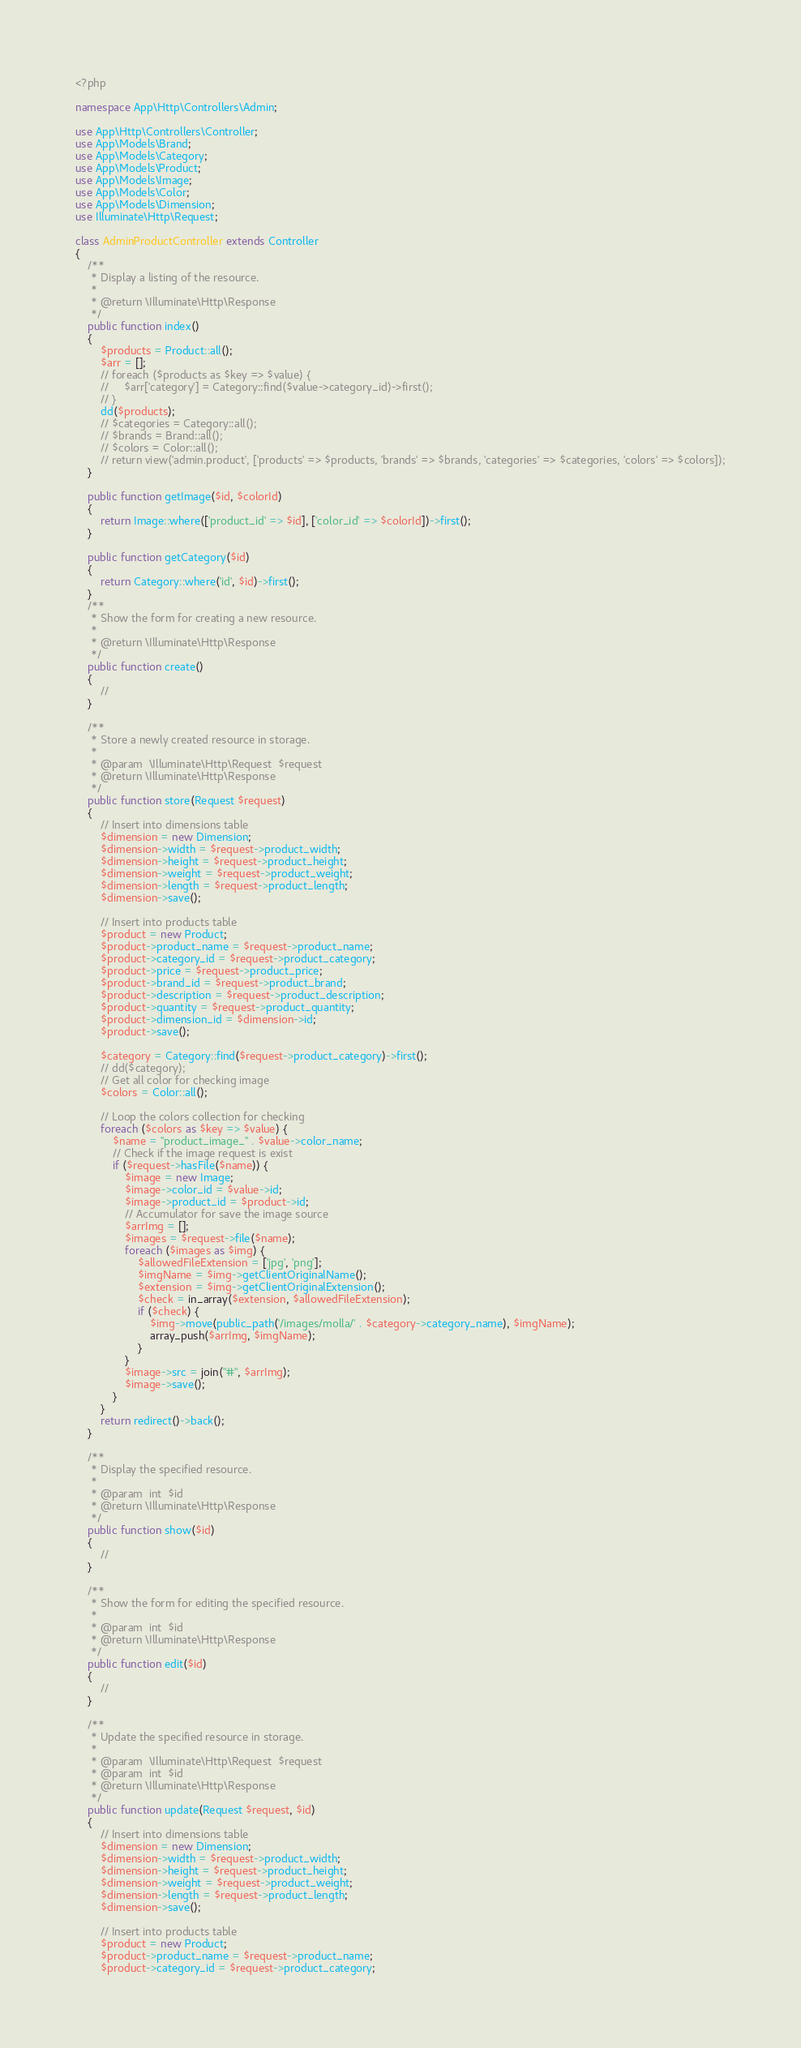<code> <loc_0><loc_0><loc_500><loc_500><_PHP_><?php

namespace App\Http\Controllers\Admin;

use App\Http\Controllers\Controller;
use App\Models\Brand;
use App\Models\Category;
use App\Models\Product;
use App\Models\Image;
use App\Models\Color;
use App\Models\Dimension;
use Illuminate\Http\Request;

class AdminProductController extends Controller
{
    /**
     * Display a listing of the resource.
     *
     * @return \Illuminate\Http\Response
     */
    public function index()
    {
        $products = Product::all();
        $arr = [];
        // foreach ($products as $key => $value) {
        //     $arr['category'] = Category::find($value->category_id)->first();
        // }
        dd($products);
        // $categories = Category::all();
        // $brands = Brand::all();
        // $colors = Color::all();
        // return view('admin.product', ['products' => $products, 'brands' => $brands, 'categories' => $categories, 'colors' => $colors]);
    }

    public function getImage($id, $colorId)
    {
        return Image::where(['product_id' => $id], ['color_id' => $colorId])->first();
    }

    public function getCategory($id)
    {
        return Category::where('id', $id)->first();
    }
    /**
     * Show the form for creating a new resource.
     *
     * @return \Illuminate\Http\Response
     */
    public function create()
    {
        //
    }

    /**
     * Store a newly created resource in storage.
     *
     * @param  \Illuminate\Http\Request  $request
     * @return \Illuminate\Http\Response
     */
    public function store(Request $request)
    {
        // Insert into dimensions table
        $dimension = new Dimension;
        $dimension->width = $request->product_width;
        $dimension->height = $request->product_height;
        $dimension->weight = $request->product_weight;
        $dimension->length = $request->product_length;
        $dimension->save();

        // Insert into products table
        $product = new Product;
        $product->product_name = $request->product_name;
        $product->category_id = $request->product_category;
        $product->price = $request->product_price;
        $product->brand_id = $request->product_brand;
        $product->description = $request->product_description;
        $product->quantity = $request->product_quantity;
        $product->dimension_id = $dimension->id;
        $product->save();

        $category = Category::find($request->product_category)->first();
        // dd($category);
        // Get all color for checking image
        $colors = Color::all();

        // Loop the colors collection for checking
        foreach ($colors as $key => $value) {
            $name = "product_image_" . $value->color_name;
            // Check if the image request is exist
            if ($request->hasFile($name)) {
                $image = new Image;
                $image->color_id = $value->id;
                $image->product_id = $product->id;
                // Accumulator for save the image source
                $arrImg = [];
                $images = $request->file($name);
                foreach ($images as $img) {
                    $allowedFileExtension = ['jpg', 'png'];
                    $imgName = $img->getClientOriginalName();
                    $extension = $img->getClientOriginalExtension();
                    $check = in_array($extension, $allowedFileExtension);
                    if ($check) {
                        $img->move(public_path('/images/molla/' . $category->category_name), $imgName);
                        array_push($arrImg, $imgName);
                    }
                }
                $image->src = join("#", $arrImg);
                $image->save();
            }
        }
        return redirect()->back();
    }

    /**
     * Display the specified resource.
     *
     * @param  int  $id
     * @return \Illuminate\Http\Response
     */
    public function show($id)
    {
        //
    }

    /**
     * Show the form for editing the specified resource.
     *
     * @param  int  $id
     * @return \Illuminate\Http\Response
     */
    public function edit($id)
    {
        //
    }

    /**
     * Update the specified resource in storage.
     *
     * @param  \Illuminate\Http\Request  $request
     * @param  int  $id
     * @return \Illuminate\Http\Response
     */
    public function update(Request $request, $id)
    {
        // Insert into dimensions table
        $dimension = new Dimension;
        $dimension->width = $request->product_width;
        $dimension->height = $request->product_height;
        $dimension->weight = $request->product_weight;
        $dimension->length = $request->product_length;
        $dimension->save();

        // Insert into products table
        $product = new Product;
        $product->product_name = $request->product_name;
        $product->category_id = $request->product_category;</code> 